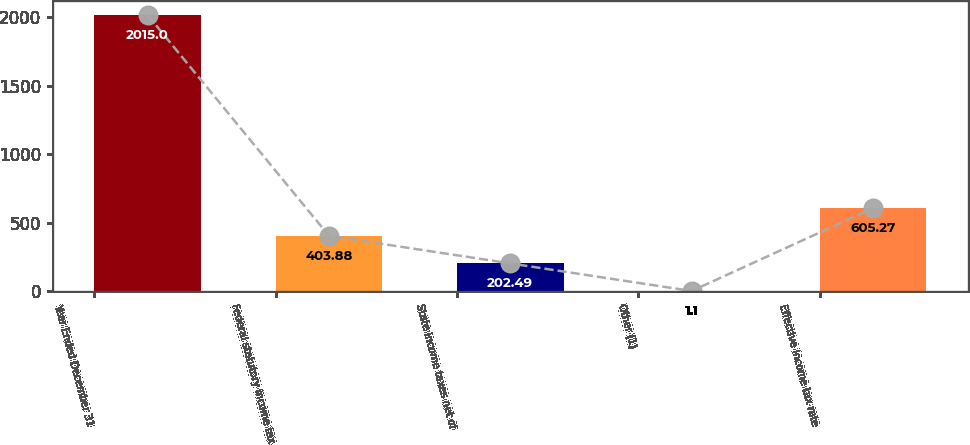Convert chart. <chart><loc_0><loc_0><loc_500><loc_500><bar_chart><fcel>Year Ended December 31<fcel>Federal statutory income tax<fcel>State income taxes net of<fcel>Other (1)<fcel>Effective income tax rate<nl><fcel>2015<fcel>403.88<fcel>202.49<fcel>1.1<fcel>605.27<nl></chart> 